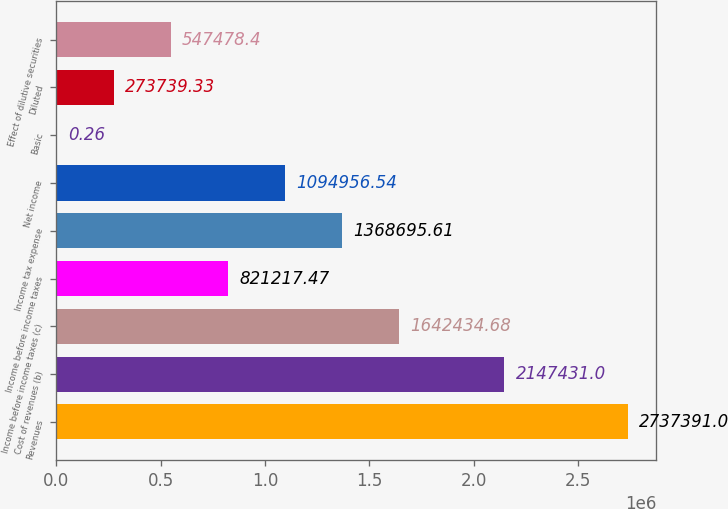Convert chart. <chart><loc_0><loc_0><loc_500><loc_500><bar_chart><fcel>Revenues<fcel>Cost of revenues (b)<fcel>Income before income taxes (c)<fcel>Income before income taxes<fcel>Income tax expense<fcel>Net income<fcel>Basic<fcel>Diluted<fcel>Effect of dilutive securities<nl><fcel>2.73739e+06<fcel>2.14743e+06<fcel>1.64243e+06<fcel>821217<fcel>1.3687e+06<fcel>1.09496e+06<fcel>0.26<fcel>273739<fcel>547478<nl></chart> 